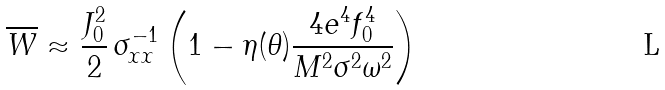Convert formula to latex. <formula><loc_0><loc_0><loc_500><loc_500>\overline { W } \approx \frac { J _ { 0 } ^ { 2 } } { 2 } \, \sigma _ { x x } ^ { - 1 } \left ( 1 - \eta ( \theta ) \frac { 4 e ^ { 4 } f _ { 0 } ^ { 4 } } { M ^ { 2 } \sigma ^ { 2 } \omega ^ { 2 } } \right )</formula> 